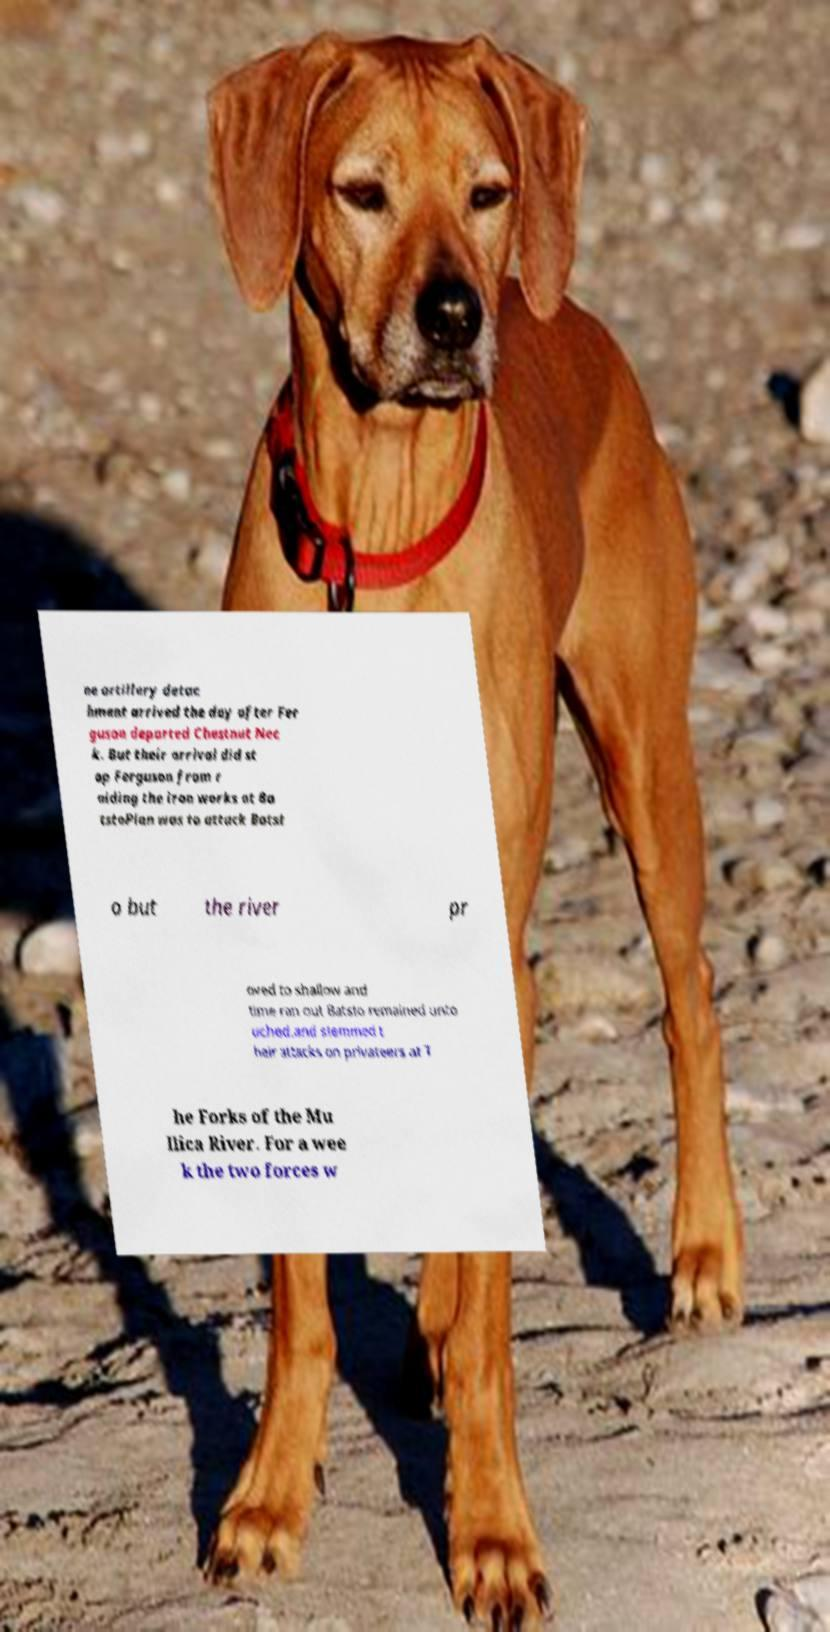What messages or text are displayed in this image? I need them in a readable, typed format. ne artillery detac hment arrived the day after Fer guson departed Chestnut Nec k. But their arrival did st op Ferguson from r aiding the iron works at Ba tstoPlan was to attack Batst o but the river pr oved to shallow and time ran out Batsto remained unto uched.and stemmed t heir attacks on privateers at T he Forks of the Mu llica River. For a wee k the two forces w 